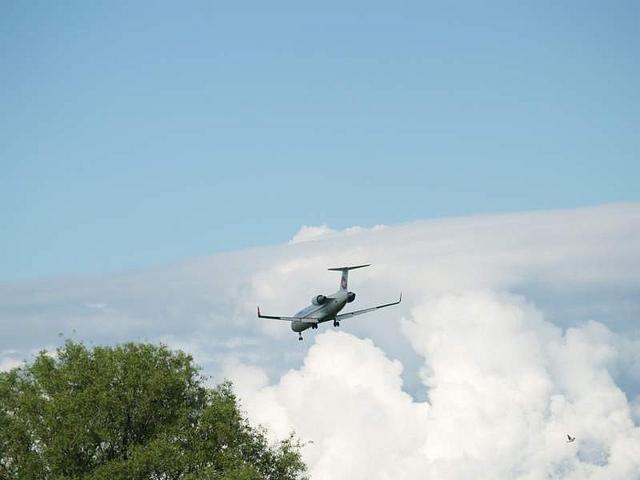What is the white line behind the two planes?
Write a very short answer. Clouds. Is this an old photo?
Give a very brief answer. No. Is this plane landing?
Quick response, please. Yes. How many birds are there?
Give a very brief answer. 1. How many planes are leaving a trail?
Keep it brief. 1. How many airplanes are there?
Quick response, please. 1. How many trees are in the picture?
Be succinct. 1. How many objects in the sky?
Answer briefly. 1. Is the plane going higher?
Short answer required. No. Is the plane going to crash?
Concise answer only. No. Why is the sky so blue?
Give a very brief answer. Clear. What kind of plane is that?
Give a very brief answer. Jet. 